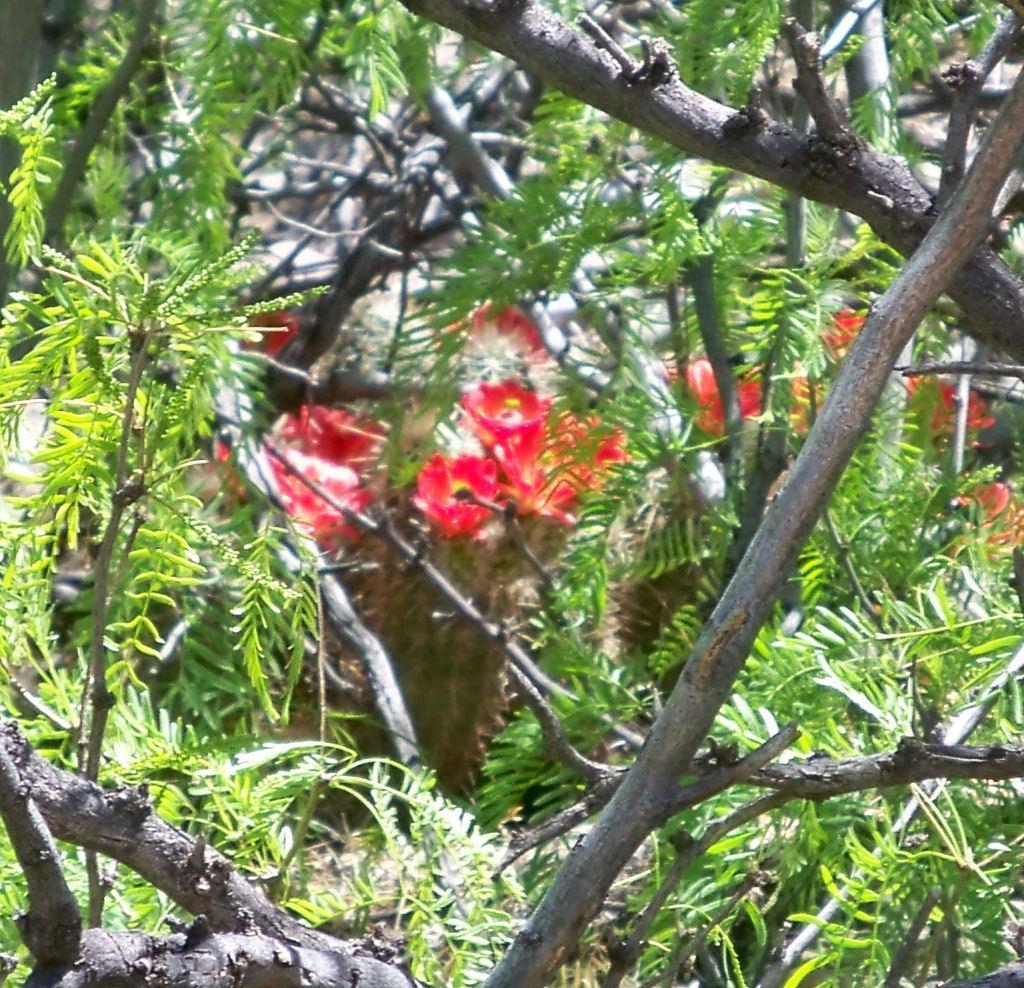In one or two sentences, can you explain what this image depicts? In this image I can see few trees and few flowers which are red in color. I can see the brown and white colored background. 